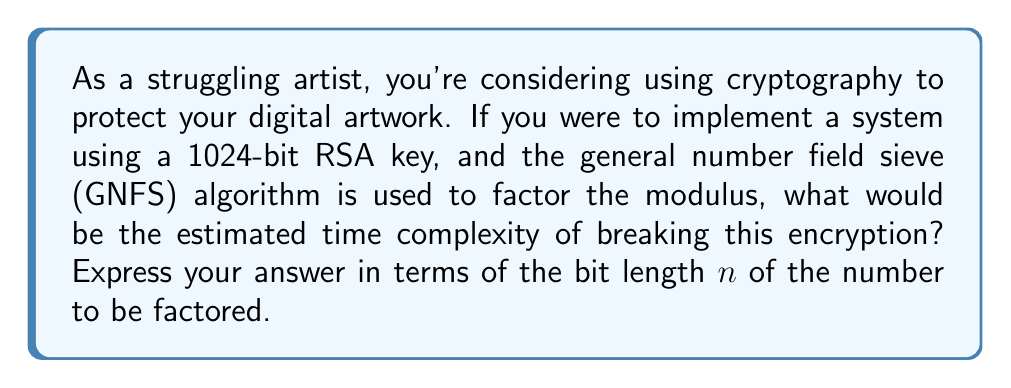Provide a solution to this math problem. To estimate the time complexity of factoring a large composite number using the general number field sieve (GNFS) algorithm, we need to follow these steps:

1. The GNFS algorithm has a subexponential time complexity.

2. The asymptotic time complexity of GNFS is generally expressed as:

   $$O(\exp((c + o(1))((\ln n)^{1/3})(\ln \ln n)^{2/3}))$$

   where $c$ is a constant and $n$ is the number to be factored.

3. The constant $c$ is approximately 1.923 for the general number field sieve.

4. The $o(1)$ term approaches zero as $n$ approaches infinity, so for large $n$, we can approximate the complexity as:

   $$O(\exp(1.923(\ln n)^{1/3}(\ln \ln n)^{2/3}))$$

5. This complexity is often simplified and written as:

   $$L_n[1/3, 1.923]$$

   where $L_n[\alpha, c]$ is the L-notation defined as:

   $$L_n[\alpha, c] = \exp((c + o(1))(\ln n)^{\alpha}(\ln \ln n)^{1-\alpha})$$

6. For a 1024-bit RSA key, $n$ would be a 1024-bit number.

Therefore, the estimated time complexity for factoring a 1024-bit RSA modulus using GNFS is $L_n[1/3, 1.923]$, where $n$ is 1024 bits long.
Answer: $L_n[1/3, 1.923]$ 